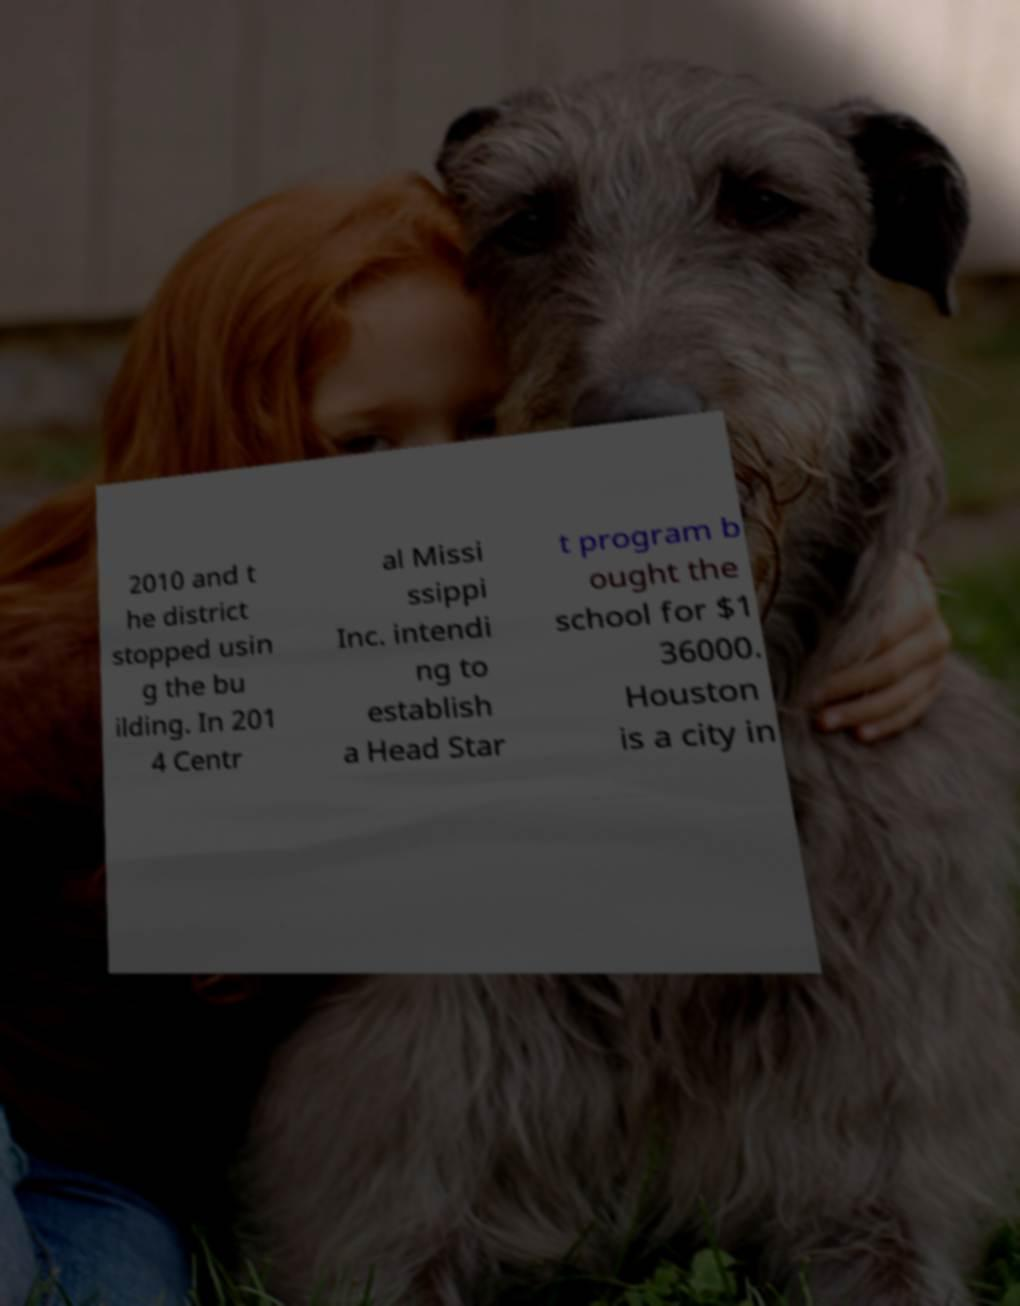I need the written content from this picture converted into text. Can you do that? 2010 and t he district stopped usin g the bu ilding. In 201 4 Centr al Missi ssippi Inc. intendi ng to establish a Head Star t program b ought the school for $1 36000. Houston is a city in 